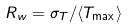<formula> <loc_0><loc_0><loc_500><loc_500>R _ { w } = \sigma _ { T } / \langle T _ { \max } \rangle</formula> 